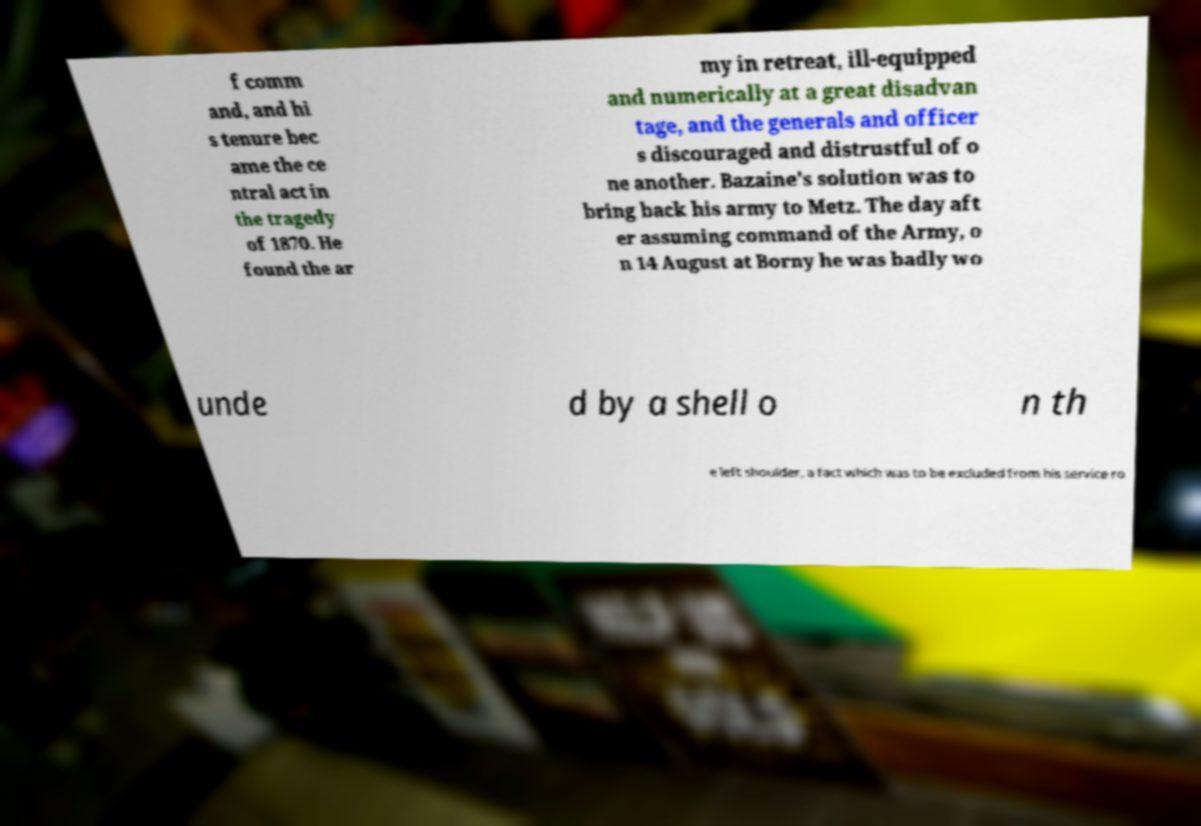There's text embedded in this image that I need extracted. Can you transcribe it verbatim? f comm and, and hi s tenure bec ame the ce ntral act in the tragedy of 1870. He found the ar my in retreat, ill-equipped and numerically at a great disadvan tage, and the generals and officer s discouraged and distrustful of o ne another. Bazaine's solution was to bring back his army to Metz. The day aft er assuming command of the Army, o n 14 August at Borny he was badly wo unde d by a shell o n th e left shoulder, a fact which was to be excluded from his service ro 